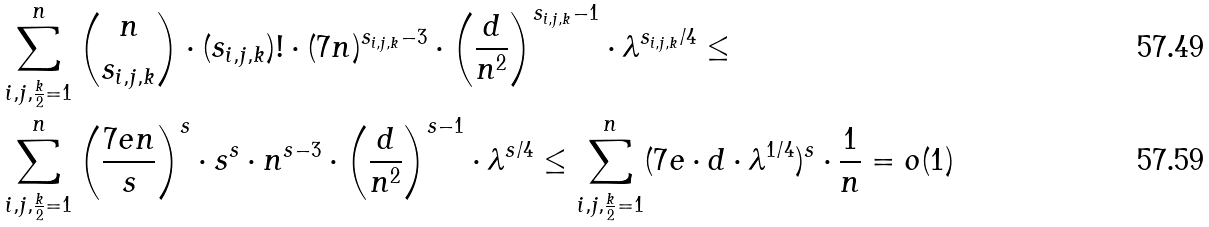<formula> <loc_0><loc_0><loc_500><loc_500>& \sum _ { i , j , \frac { k } { 2 } = 1 } ^ { n } \binom { n } { s _ { i , j , k } } \cdot ( s _ { i , j , k } ) ! \cdot ( 7 n ) ^ { s _ { i , j , k } - 3 } \cdot \left ( \frac { d } { n ^ { 2 } } \right ) ^ { s _ { i , j , k } - 1 } \cdot \lambda ^ { s _ { i , j , k } / 4 } \leq \\ & \sum _ { i , j , \frac { k } { 2 } = 1 } ^ { n } \left ( \frac { 7 e n } { s } \right ) ^ { s } \cdot s ^ { s } \cdot n ^ { s - 3 } \cdot \left ( \frac { d } { n ^ { 2 } } \right ) ^ { s - 1 } \cdot \lambda ^ { s / 4 } \leq \sum _ { i , j , \frac { k } { 2 } = 1 } ^ { n } ( 7 e \cdot d \cdot \lambda ^ { 1 / 4 } ) ^ { s } \cdot \frac { 1 } { n } = o ( 1 )</formula> 